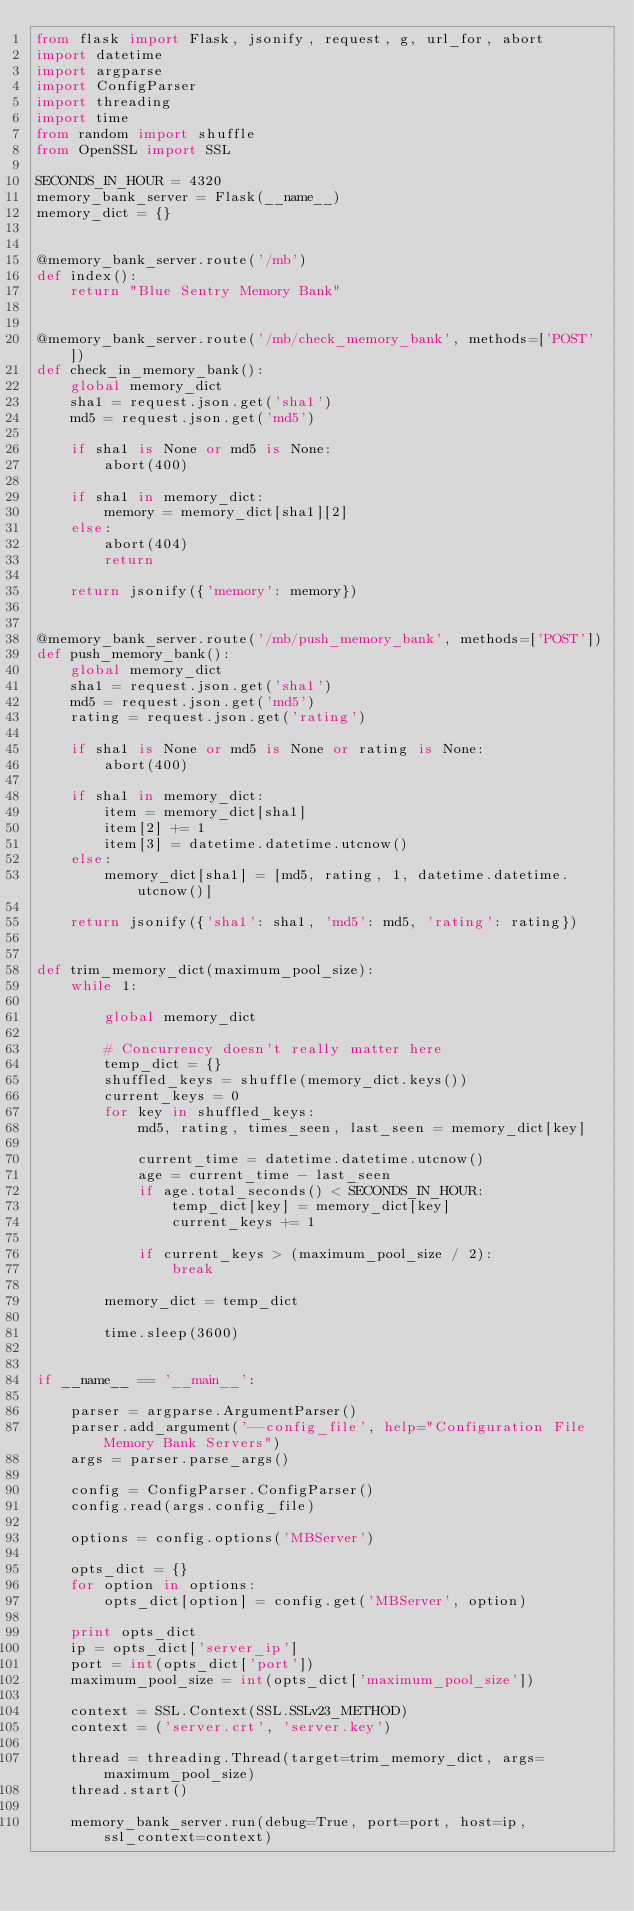<code> <loc_0><loc_0><loc_500><loc_500><_Python_>from flask import Flask, jsonify, request, g, url_for, abort
import datetime
import argparse
import ConfigParser
import threading
import time
from random import shuffle
from OpenSSL import SSL

SECONDS_IN_HOUR = 4320
memory_bank_server = Flask(__name__)
memory_dict = {}


@memory_bank_server.route('/mb')
def index():
    return "Blue Sentry Memory Bank"


@memory_bank_server.route('/mb/check_memory_bank', methods=['POST'])
def check_in_memory_bank():
    global memory_dict
    sha1 = request.json.get('sha1')
    md5 = request.json.get('md5')

    if sha1 is None or md5 is None:
        abort(400)

    if sha1 in memory_dict:
        memory = memory_dict[sha1][2]
    else:
        abort(404)
        return

    return jsonify({'memory': memory})


@memory_bank_server.route('/mb/push_memory_bank', methods=['POST'])
def push_memory_bank():
    global memory_dict
    sha1 = request.json.get('sha1')
    md5 = request.json.get('md5')
    rating = request.json.get('rating')

    if sha1 is None or md5 is None or rating is None:
        abort(400)

    if sha1 in memory_dict:
        item = memory_dict[sha1]
        item[2] += 1
        item[3] = datetime.datetime.utcnow()
    else:
        memory_dict[sha1] = [md5, rating, 1, datetime.datetime.utcnow()]

    return jsonify({'sha1': sha1, 'md5': md5, 'rating': rating})


def trim_memory_dict(maximum_pool_size):
    while 1:

        global memory_dict

        # Concurrency doesn't really matter here
        temp_dict = {}
        shuffled_keys = shuffle(memory_dict.keys())
        current_keys = 0
        for key in shuffled_keys:
            md5, rating, times_seen, last_seen = memory_dict[key]

            current_time = datetime.datetime.utcnow()
            age = current_time - last_seen
            if age.total_seconds() < SECONDS_IN_HOUR:
                temp_dict[key] = memory_dict[key]
                current_keys += 1

            if current_keys > (maximum_pool_size / 2):
                break

        memory_dict = temp_dict

        time.sleep(3600)


if __name__ == '__main__':

    parser = argparse.ArgumentParser()
    parser.add_argument('--config_file', help="Configuration File Memory Bank Servers")
    args = parser.parse_args()

    config = ConfigParser.ConfigParser()
    config.read(args.config_file)

    options = config.options('MBServer')

    opts_dict = {}
    for option in options:
        opts_dict[option] = config.get('MBServer', option)

    print opts_dict
    ip = opts_dict['server_ip']
    port = int(opts_dict['port'])
    maximum_pool_size = int(opts_dict['maximum_pool_size'])

    context = SSL.Context(SSL.SSLv23_METHOD)
    context = ('server.crt', 'server.key')

    thread = threading.Thread(target=trim_memory_dict, args=maximum_pool_size)
    thread.start()

    memory_bank_server.run(debug=True, port=port, host=ip, ssl_context=context)
</code> 